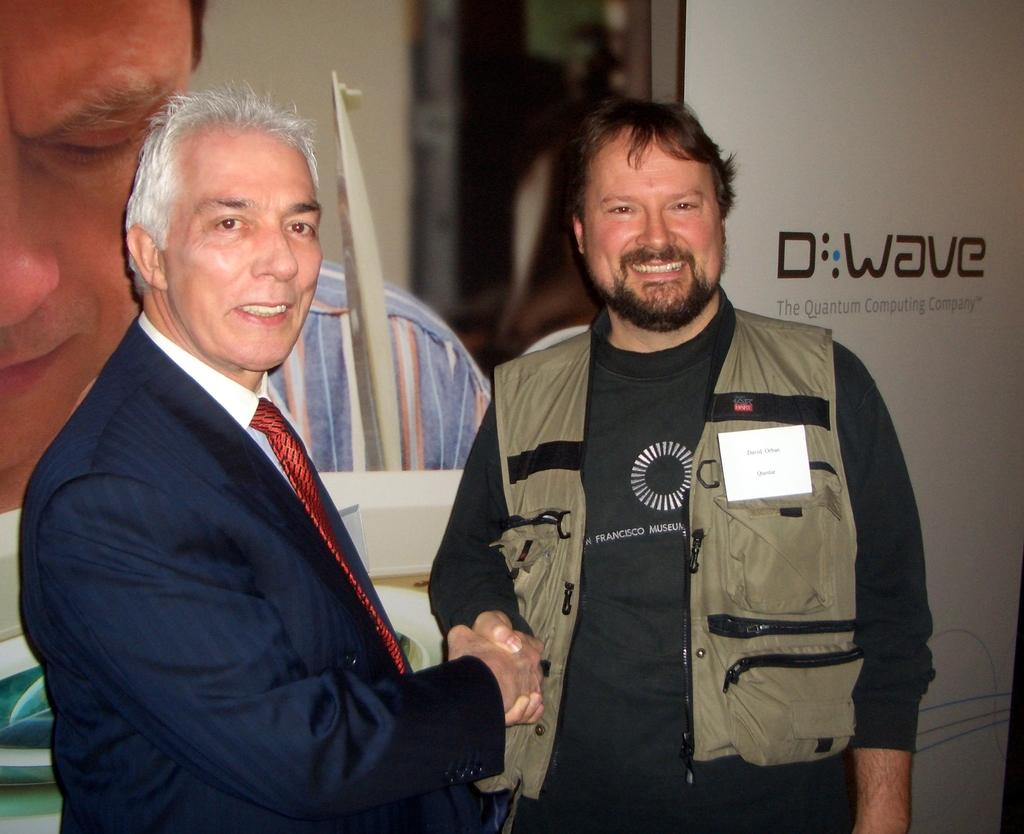How many people are in the image? There are two persons in the image. What are the two persons doing? The two persons are shaking hands. What can be seen in the background of the image? There is a banner visible in the background of the image. What type of stem can be seen on the tail of one of the persons in the image? There is no stem or tail present on any of the persons in the image. 